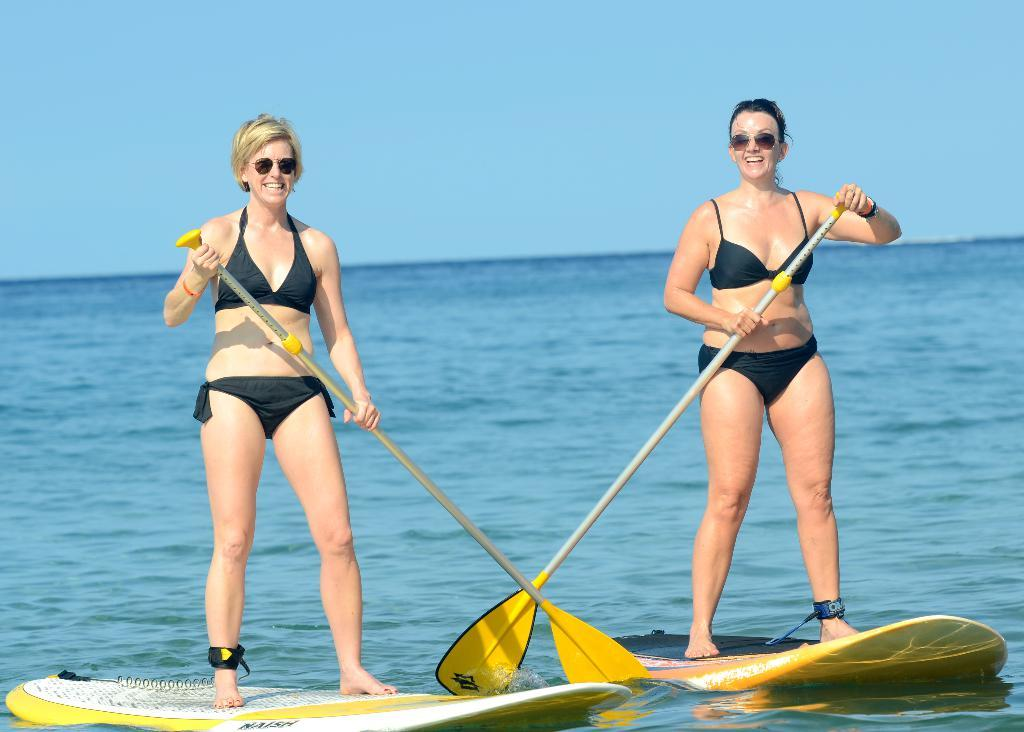How many people are in the image? There are two persons in the image. What are the persons holding in their hands? The persons are holding paddles. What are the persons standing on? The persons are standing on surfboards. Where are the surfboards located? The surfboards are on the water. What can be seen in the background of the image? The sky is visible in the background of the image. What type of creature can be seen swimming under the surfboards in the image? There is no creature visible under the surfboards in the image. Can you tell me how many loaves of bread are present in the image? There are no loaves of bread present in the image. 